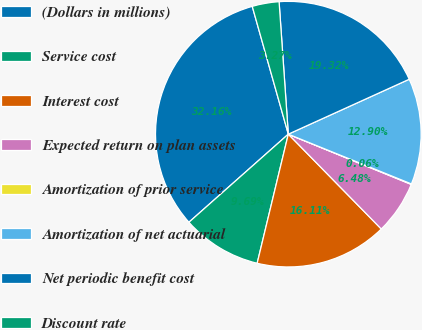<chart> <loc_0><loc_0><loc_500><loc_500><pie_chart><fcel>(Dollars in millions)<fcel>Service cost<fcel>Interest cost<fcel>Expected return on plan assets<fcel>Amortization of prior service<fcel>Amortization of net actuarial<fcel>Net periodic benefit cost<fcel>Discount rate<nl><fcel>32.16%<fcel>9.69%<fcel>16.11%<fcel>6.48%<fcel>0.06%<fcel>12.9%<fcel>19.32%<fcel>3.27%<nl></chart> 